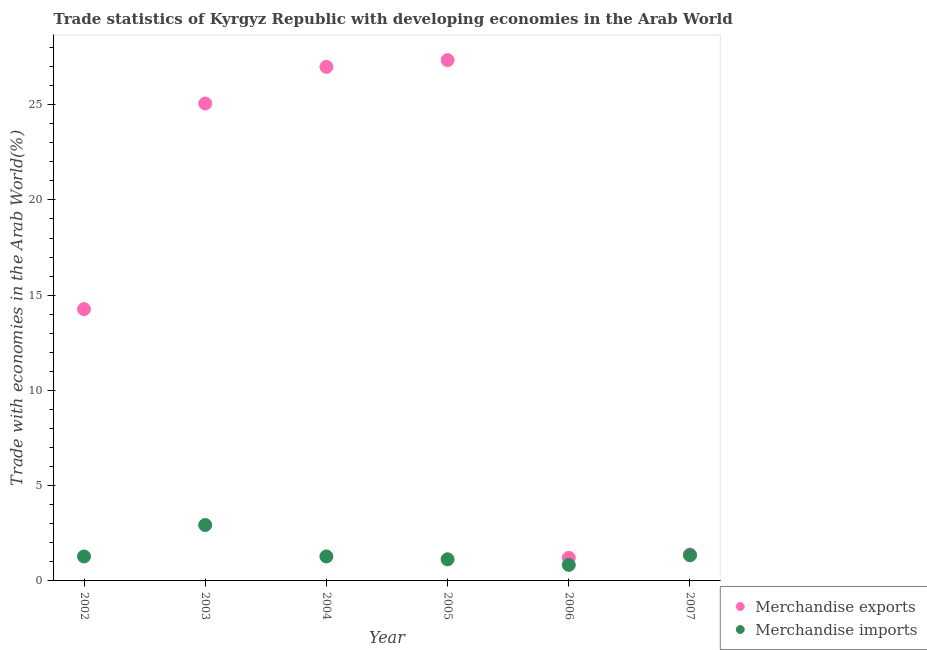How many different coloured dotlines are there?
Your response must be concise. 2. Is the number of dotlines equal to the number of legend labels?
Your answer should be very brief. Yes. What is the merchandise exports in 2002?
Provide a short and direct response. 14.27. Across all years, what is the maximum merchandise exports?
Give a very brief answer. 27.34. Across all years, what is the minimum merchandise exports?
Provide a succinct answer. 1.21. In which year was the merchandise imports maximum?
Provide a short and direct response. 2003. In which year was the merchandise exports minimum?
Your response must be concise. 2006. What is the total merchandise exports in the graph?
Offer a very short reply. 96.24. What is the difference between the merchandise imports in 2003 and that in 2007?
Give a very brief answer. 1.59. What is the difference between the merchandise exports in 2007 and the merchandise imports in 2002?
Keep it short and to the point. 0.1. What is the average merchandise exports per year?
Offer a terse response. 16.04. In the year 2002, what is the difference between the merchandise imports and merchandise exports?
Your answer should be very brief. -12.98. In how many years, is the merchandise exports greater than 20 %?
Provide a short and direct response. 3. What is the ratio of the merchandise imports in 2005 to that in 2006?
Your answer should be very brief. 1.35. Is the difference between the merchandise imports in 2002 and 2004 greater than the difference between the merchandise exports in 2002 and 2004?
Offer a very short reply. Yes. What is the difference between the highest and the second highest merchandise exports?
Your response must be concise. 0.35. What is the difference between the highest and the lowest merchandise exports?
Your answer should be very brief. 26.13. In how many years, is the merchandise exports greater than the average merchandise exports taken over all years?
Give a very brief answer. 3. Is the merchandise exports strictly greater than the merchandise imports over the years?
Your response must be concise. Yes. Is the merchandise imports strictly less than the merchandise exports over the years?
Your response must be concise. Yes. How many dotlines are there?
Your answer should be very brief. 2. How many years are there in the graph?
Provide a short and direct response. 6. What is the difference between two consecutive major ticks on the Y-axis?
Keep it short and to the point. 5. Does the graph contain any zero values?
Your answer should be very brief. No. Does the graph contain grids?
Offer a very short reply. No. Where does the legend appear in the graph?
Provide a succinct answer. Bottom right. How are the legend labels stacked?
Your response must be concise. Vertical. What is the title of the graph?
Offer a terse response. Trade statistics of Kyrgyz Republic with developing economies in the Arab World. Does "Food" appear as one of the legend labels in the graph?
Provide a short and direct response. No. What is the label or title of the Y-axis?
Give a very brief answer. Trade with economies in the Arab World(%). What is the Trade with economies in the Arab World(%) of Merchandise exports in 2002?
Ensure brevity in your answer.  14.27. What is the Trade with economies in the Arab World(%) in Merchandise imports in 2002?
Keep it short and to the point. 1.28. What is the Trade with economies in the Arab World(%) in Merchandise exports in 2003?
Your response must be concise. 25.06. What is the Trade with economies in the Arab World(%) in Merchandise imports in 2003?
Your response must be concise. 2.93. What is the Trade with economies in the Arab World(%) of Merchandise exports in 2004?
Give a very brief answer. 26.98. What is the Trade with economies in the Arab World(%) in Merchandise imports in 2004?
Provide a short and direct response. 1.29. What is the Trade with economies in the Arab World(%) in Merchandise exports in 2005?
Give a very brief answer. 27.34. What is the Trade with economies in the Arab World(%) in Merchandise imports in 2005?
Provide a short and direct response. 1.13. What is the Trade with economies in the Arab World(%) of Merchandise exports in 2006?
Keep it short and to the point. 1.21. What is the Trade with economies in the Arab World(%) in Merchandise imports in 2006?
Make the answer very short. 0.84. What is the Trade with economies in the Arab World(%) of Merchandise exports in 2007?
Give a very brief answer. 1.39. What is the Trade with economies in the Arab World(%) of Merchandise imports in 2007?
Offer a very short reply. 1.35. Across all years, what is the maximum Trade with economies in the Arab World(%) of Merchandise exports?
Ensure brevity in your answer.  27.34. Across all years, what is the maximum Trade with economies in the Arab World(%) of Merchandise imports?
Offer a terse response. 2.93. Across all years, what is the minimum Trade with economies in the Arab World(%) in Merchandise exports?
Offer a terse response. 1.21. Across all years, what is the minimum Trade with economies in the Arab World(%) in Merchandise imports?
Provide a succinct answer. 0.84. What is the total Trade with economies in the Arab World(%) in Merchandise exports in the graph?
Offer a terse response. 96.24. What is the total Trade with economies in the Arab World(%) in Merchandise imports in the graph?
Keep it short and to the point. 8.83. What is the difference between the Trade with economies in the Arab World(%) of Merchandise exports in 2002 and that in 2003?
Your answer should be very brief. -10.79. What is the difference between the Trade with economies in the Arab World(%) in Merchandise imports in 2002 and that in 2003?
Your answer should be compact. -1.65. What is the difference between the Trade with economies in the Arab World(%) of Merchandise exports in 2002 and that in 2004?
Give a very brief answer. -12.72. What is the difference between the Trade with economies in the Arab World(%) of Merchandise imports in 2002 and that in 2004?
Give a very brief answer. -0. What is the difference between the Trade with economies in the Arab World(%) of Merchandise exports in 2002 and that in 2005?
Offer a very short reply. -13.07. What is the difference between the Trade with economies in the Arab World(%) of Merchandise imports in 2002 and that in 2005?
Ensure brevity in your answer.  0.15. What is the difference between the Trade with economies in the Arab World(%) of Merchandise exports in 2002 and that in 2006?
Make the answer very short. 13.05. What is the difference between the Trade with economies in the Arab World(%) of Merchandise imports in 2002 and that in 2006?
Give a very brief answer. 0.44. What is the difference between the Trade with economies in the Arab World(%) in Merchandise exports in 2002 and that in 2007?
Provide a short and direct response. 12.88. What is the difference between the Trade with economies in the Arab World(%) of Merchandise imports in 2002 and that in 2007?
Your response must be concise. -0.06. What is the difference between the Trade with economies in the Arab World(%) of Merchandise exports in 2003 and that in 2004?
Ensure brevity in your answer.  -1.92. What is the difference between the Trade with economies in the Arab World(%) in Merchandise imports in 2003 and that in 2004?
Offer a very short reply. 1.65. What is the difference between the Trade with economies in the Arab World(%) of Merchandise exports in 2003 and that in 2005?
Make the answer very short. -2.28. What is the difference between the Trade with economies in the Arab World(%) of Merchandise imports in 2003 and that in 2005?
Provide a short and direct response. 1.8. What is the difference between the Trade with economies in the Arab World(%) in Merchandise exports in 2003 and that in 2006?
Your response must be concise. 23.85. What is the difference between the Trade with economies in the Arab World(%) of Merchandise imports in 2003 and that in 2006?
Offer a very short reply. 2.09. What is the difference between the Trade with economies in the Arab World(%) of Merchandise exports in 2003 and that in 2007?
Give a very brief answer. 23.67. What is the difference between the Trade with economies in the Arab World(%) in Merchandise imports in 2003 and that in 2007?
Give a very brief answer. 1.59. What is the difference between the Trade with economies in the Arab World(%) in Merchandise exports in 2004 and that in 2005?
Your response must be concise. -0.35. What is the difference between the Trade with economies in the Arab World(%) in Merchandise imports in 2004 and that in 2005?
Ensure brevity in your answer.  0.15. What is the difference between the Trade with economies in the Arab World(%) in Merchandise exports in 2004 and that in 2006?
Your response must be concise. 25.77. What is the difference between the Trade with economies in the Arab World(%) of Merchandise imports in 2004 and that in 2006?
Your answer should be very brief. 0.44. What is the difference between the Trade with economies in the Arab World(%) in Merchandise exports in 2004 and that in 2007?
Your response must be concise. 25.6. What is the difference between the Trade with economies in the Arab World(%) of Merchandise imports in 2004 and that in 2007?
Your response must be concise. -0.06. What is the difference between the Trade with economies in the Arab World(%) in Merchandise exports in 2005 and that in 2006?
Offer a terse response. 26.13. What is the difference between the Trade with economies in the Arab World(%) in Merchandise imports in 2005 and that in 2006?
Give a very brief answer. 0.29. What is the difference between the Trade with economies in the Arab World(%) of Merchandise exports in 2005 and that in 2007?
Your answer should be compact. 25.95. What is the difference between the Trade with economies in the Arab World(%) in Merchandise imports in 2005 and that in 2007?
Keep it short and to the point. -0.21. What is the difference between the Trade with economies in the Arab World(%) of Merchandise exports in 2006 and that in 2007?
Your response must be concise. -0.17. What is the difference between the Trade with economies in the Arab World(%) in Merchandise imports in 2006 and that in 2007?
Your response must be concise. -0.51. What is the difference between the Trade with economies in the Arab World(%) of Merchandise exports in 2002 and the Trade with economies in the Arab World(%) of Merchandise imports in 2003?
Offer a terse response. 11.33. What is the difference between the Trade with economies in the Arab World(%) in Merchandise exports in 2002 and the Trade with economies in the Arab World(%) in Merchandise imports in 2004?
Your response must be concise. 12.98. What is the difference between the Trade with economies in the Arab World(%) in Merchandise exports in 2002 and the Trade with economies in the Arab World(%) in Merchandise imports in 2005?
Your answer should be very brief. 13.13. What is the difference between the Trade with economies in the Arab World(%) in Merchandise exports in 2002 and the Trade with economies in the Arab World(%) in Merchandise imports in 2006?
Offer a very short reply. 13.42. What is the difference between the Trade with economies in the Arab World(%) of Merchandise exports in 2002 and the Trade with economies in the Arab World(%) of Merchandise imports in 2007?
Your answer should be compact. 12.92. What is the difference between the Trade with economies in the Arab World(%) of Merchandise exports in 2003 and the Trade with economies in the Arab World(%) of Merchandise imports in 2004?
Offer a terse response. 23.77. What is the difference between the Trade with economies in the Arab World(%) of Merchandise exports in 2003 and the Trade with economies in the Arab World(%) of Merchandise imports in 2005?
Offer a very short reply. 23.92. What is the difference between the Trade with economies in the Arab World(%) in Merchandise exports in 2003 and the Trade with economies in the Arab World(%) in Merchandise imports in 2006?
Provide a short and direct response. 24.22. What is the difference between the Trade with economies in the Arab World(%) of Merchandise exports in 2003 and the Trade with economies in the Arab World(%) of Merchandise imports in 2007?
Provide a succinct answer. 23.71. What is the difference between the Trade with economies in the Arab World(%) of Merchandise exports in 2004 and the Trade with economies in the Arab World(%) of Merchandise imports in 2005?
Provide a succinct answer. 25.85. What is the difference between the Trade with economies in the Arab World(%) of Merchandise exports in 2004 and the Trade with economies in the Arab World(%) of Merchandise imports in 2006?
Your answer should be very brief. 26.14. What is the difference between the Trade with economies in the Arab World(%) of Merchandise exports in 2004 and the Trade with economies in the Arab World(%) of Merchandise imports in 2007?
Your answer should be very brief. 25.64. What is the difference between the Trade with economies in the Arab World(%) in Merchandise exports in 2005 and the Trade with economies in the Arab World(%) in Merchandise imports in 2006?
Keep it short and to the point. 26.5. What is the difference between the Trade with economies in the Arab World(%) in Merchandise exports in 2005 and the Trade with economies in the Arab World(%) in Merchandise imports in 2007?
Offer a very short reply. 25.99. What is the difference between the Trade with economies in the Arab World(%) in Merchandise exports in 2006 and the Trade with economies in the Arab World(%) in Merchandise imports in 2007?
Offer a very short reply. -0.14. What is the average Trade with economies in the Arab World(%) in Merchandise exports per year?
Offer a very short reply. 16.04. What is the average Trade with economies in the Arab World(%) of Merchandise imports per year?
Your answer should be compact. 1.47. In the year 2002, what is the difference between the Trade with economies in the Arab World(%) in Merchandise exports and Trade with economies in the Arab World(%) in Merchandise imports?
Your answer should be compact. 12.98. In the year 2003, what is the difference between the Trade with economies in the Arab World(%) in Merchandise exports and Trade with economies in the Arab World(%) in Merchandise imports?
Offer a very short reply. 22.13. In the year 2004, what is the difference between the Trade with economies in the Arab World(%) in Merchandise exports and Trade with economies in the Arab World(%) in Merchandise imports?
Provide a succinct answer. 25.7. In the year 2005, what is the difference between the Trade with economies in the Arab World(%) in Merchandise exports and Trade with economies in the Arab World(%) in Merchandise imports?
Your response must be concise. 26.2. In the year 2006, what is the difference between the Trade with economies in the Arab World(%) in Merchandise exports and Trade with economies in the Arab World(%) in Merchandise imports?
Your response must be concise. 0.37. In the year 2007, what is the difference between the Trade with economies in the Arab World(%) in Merchandise exports and Trade with economies in the Arab World(%) in Merchandise imports?
Offer a terse response. 0.04. What is the ratio of the Trade with economies in the Arab World(%) in Merchandise exports in 2002 to that in 2003?
Make the answer very short. 0.57. What is the ratio of the Trade with economies in the Arab World(%) in Merchandise imports in 2002 to that in 2003?
Provide a short and direct response. 0.44. What is the ratio of the Trade with economies in the Arab World(%) in Merchandise exports in 2002 to that in 2004?
Keep it short and to the point. 0.53. What is the ratio of the Trade with economies in the Arab World(%) in Merchandise imports in 2002 to that in 2004?
Your response must be concise. 1. What is the ratio of the Trade with economies in the Arab World(%) in Merchandise exports in 2002 to that in 2005?
Offer a very short reply. 0.52. What is the ratio of the Trade with economies in the Arab World(%) in Merchandise imports in 2002 to that in 2005?
Keep it short and to the point. 1.13. What is the ratio of the Trade with economies in the Arab World(%) in Merchandise exports in 2002 to that in 2006?
Make the answer very short. 11.77. What is the ratio of the Trade with economies in the Arab World(%) of Merchandise imports in 2002 to that in 2006?
Ensure brevity in your answer.  1.53. What is the ratio of the Trade with economies in the Arab World(%) of Merchandise exports in 2002 to that in 2007?
Provide a short and direct response. 10.29. What is the ratio of the Trade with economies in the Arab World(%) of Merchandise imports in 2002 to that in 2007?
Offer a terse response. 0.95. What is the ratio of the Trade with economies in the Arab World(%) of Merchandise exports in 2003 to that in 2004?
Your answer should be very brief. 0.93. What is the ratio of the Trade with economies in the Arab World(%) of Merchandise imports in 2003 to that in 2004?
Give a very brief answer. 2.28. What is the ratio of the Trade with economies in the Arab World(%) in Merchandise imports in 2003 to that in 2005?
Offer a very short reply. 2.59. What is the ratio of the Trade with economies in the Arab World(%) of Merchandise exports in 2003 to that in 2006?
Provide a succinct answer. 20.67. What is the ratio of the Trade with economies in the Arab World(%) in Merchandise imports in 2003 to that in 2006?
Offer a very short reply. 3.49. What is the ratio of the Trade with economies in the Arab World(%) of Merchandise exports in 2003 to that in 2007?
Offer a very short reply. 18.08. What is the ratio of the Trade with economies in the Arab World(%) in Merchandise imports in 2003 to that in 2007?
Keep it short and to the point. 2.18. What is the ratio of the Trade with economies in the Arab World(%) in Merchandise exports in 2004 to that in 2005?
Provide a succinct answer. 0.99. What is the ratio of the Trade with economies in the Arab World(%) of Merchandise imports in 2004 to that in 2005?
Offer a very short reply. 1.13. What is the ratio of the Trade with economies in the Arab World(%) of Merchandise exports in 2004 to that in 2006?
Your answer should be compact. 22.26. What is the ratio of the Trade with economies in the Arab World(%) in Merchandise imports in 2004 to that in 2006?
Offer a very short reply. 1.53. What is the ratio of the Trade with economies in the Arab World(%) of Merchandise exports in 2004 to that in 2007?
Ensure brevity in your answer.  19.47. What is the ratio of the Trade with economies in the Arab World(%) in Merchandise imports in 2004 to that in 2007?
Ensure brevity in your answer.  0.95. What is the ratio of the Trade with economies in the Arab World(%) in Merchandise exports in 2005 to that in 2006?
Provide a short and direct response. 22.55. What is the ratio of the Trade with economies in the Arab World(%) in Merchandise imports in 2005 to that in 2006?
Provide a succinct answer. 1.35. What is the ratio of the Trade with economies in the Arab World(%) in Merchandise exports in 2005 to that in 2007?
Offer a very short reply. 19.73. What is the ratio of the Trade with economies in the Arab World(%) in Merchandise imports in 2005 to that in 2007?
Provide a succinct answer. 0.84. What is the ratio of the Trade with economies in the Arab World(%) in Merchandise exports in 2006 to that in 2007?
Your response must be concise. 0.87. What is the ratio of the Trade with economies in the Arab World(%) in Merchandise imports in 2006 to that in 2007?
Provide a short and direct response. 0.62. What is the difference between the highest and the second highest Trade with economies in the Arab World(%) in Merchandise exports?
Provide a short and direct response. 0.35. What is the difference between the highest and the second highest Trade with economies in the Arab World(%) in Merchandise imports?
Provide a succinct answer. 1.59. What is the difference between the highest and the lowest Trade with economies in the Arab World(%) of Merchandise exports?
Your answer should be compact. 26.13. What is the difference between the highest and the lowest Trade with economies in the Arab World(%) in Merchandise imports?
Give a very brief answer. 2.09. 